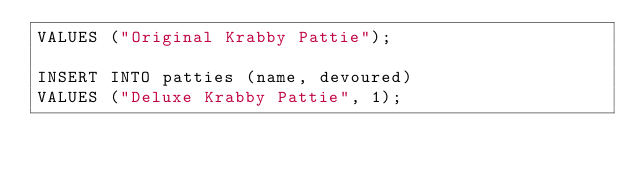<code> <loc_0><loc_0><loc_500><loc_500><_SQL_>VALUES ("Original Krabby Pattie");

INSERT INTO patties (name, devoured)
VALUES ("Deluxe Krabby Pattie", 1);</code> 